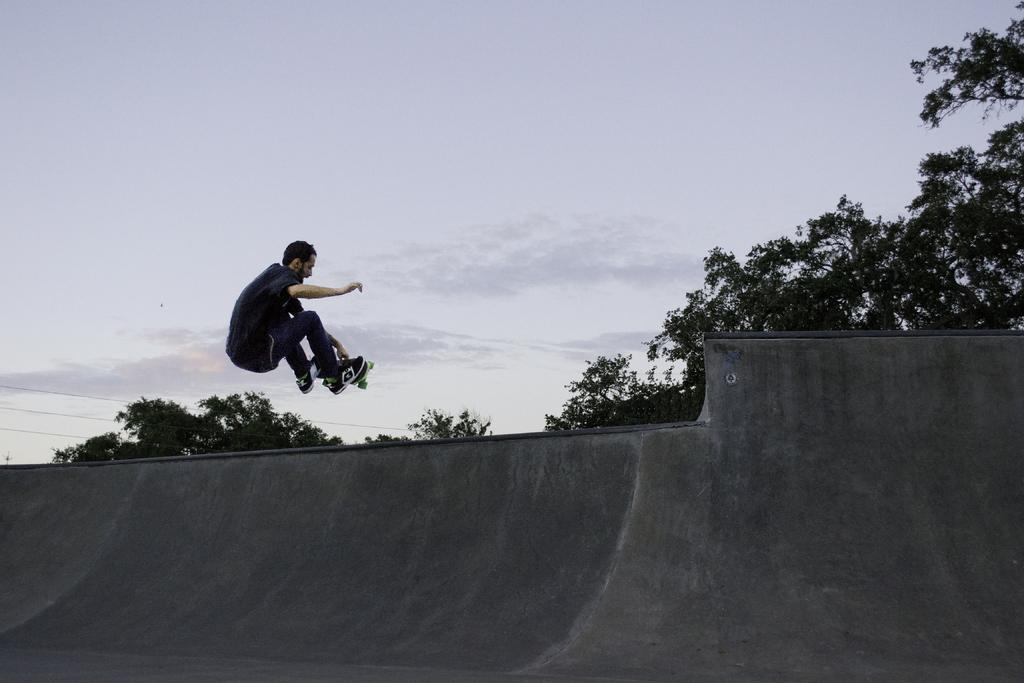What is the person in the image doing? There is a person riding a skateboard in the image. What can be seen in the background of the image? Trees and the sky are visible in the background of the image. What is the location of the wall in the image? There is a wall in the image. How many chairs are visible in the image? There are no chairs present in the image. What part of the person's brain can be seen in the image? There is no part of the person's brain visible in the image. 